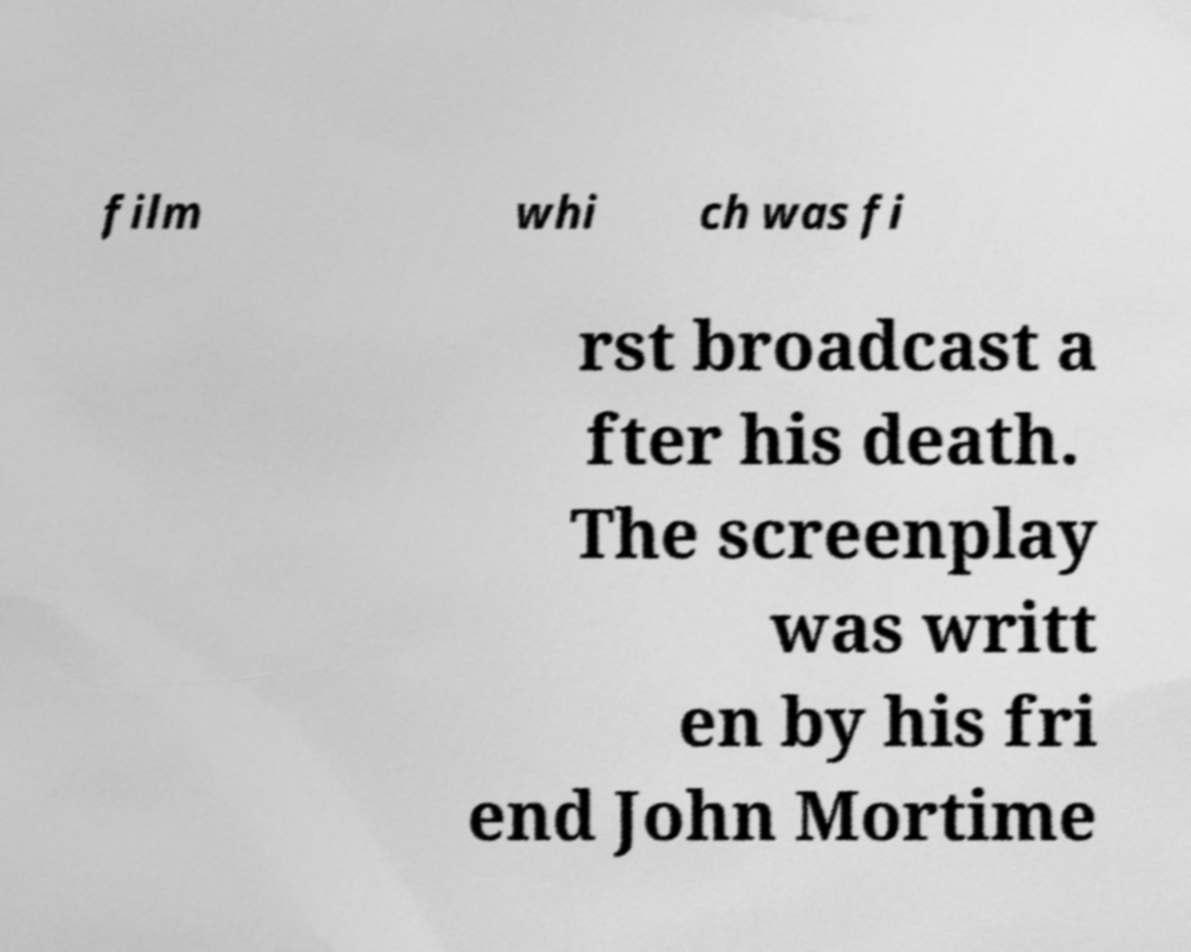Could you assist in decoding the text presented in this image and type it out clearly? film whi ch was fi rst broadcast a fter his death. The screenplay was writt en by his fri end John Mortime 